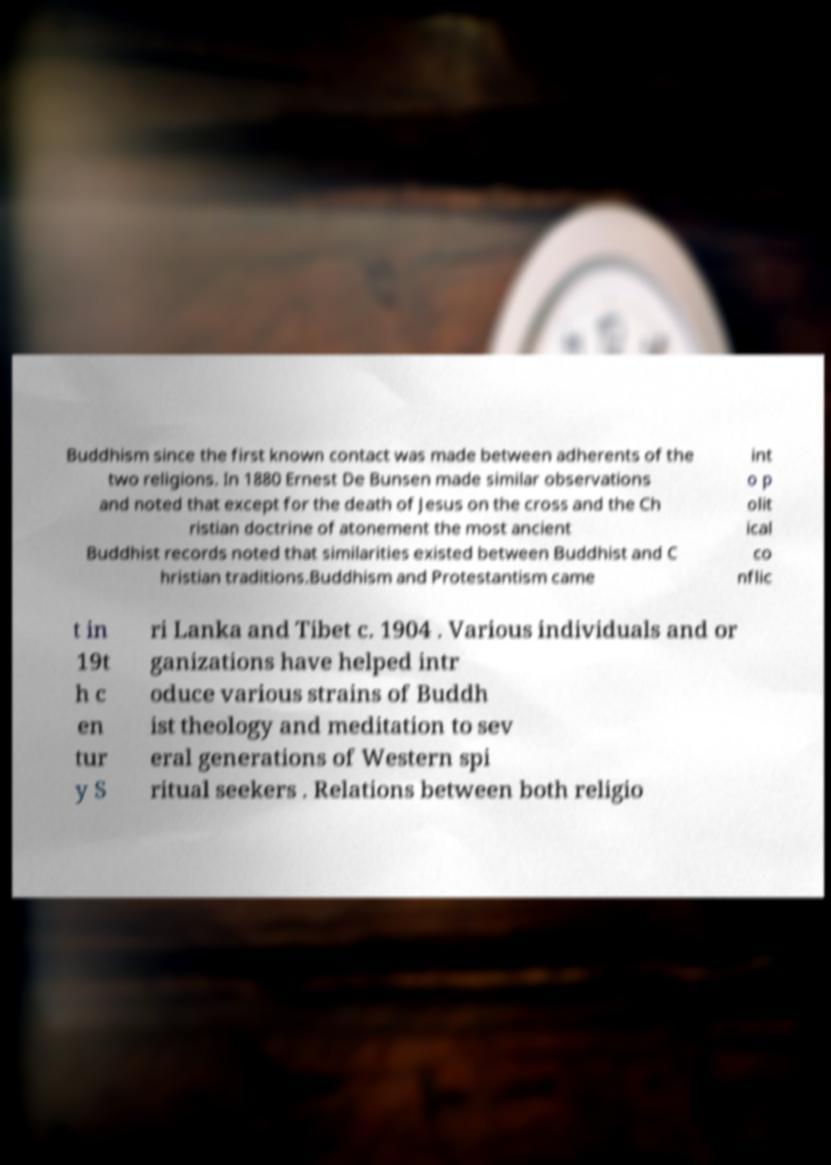I need the written content from this picture converted into text. Can you do that? Buddhism since the first known contact was made between adherents of the two religions. In 1880 Ernest De Bunsen made similar observations and noted that except for the death of Jesus on the cross and the Ch ristian doctrine of atonement the most ancient Buddhist records noted that similarities existed between Buddhist and C hristian traditions.Buddhism and Protestantism came int o p olit ical co nflic t in 19t h c en tur y S ri Lanka and Tibet c. 1904 . Various individuals and or ganizations have helped intr oduce various strains of Buddh ist theology and meditation to sev eral generations of Western spi ritual seekers . Relations between both religio 